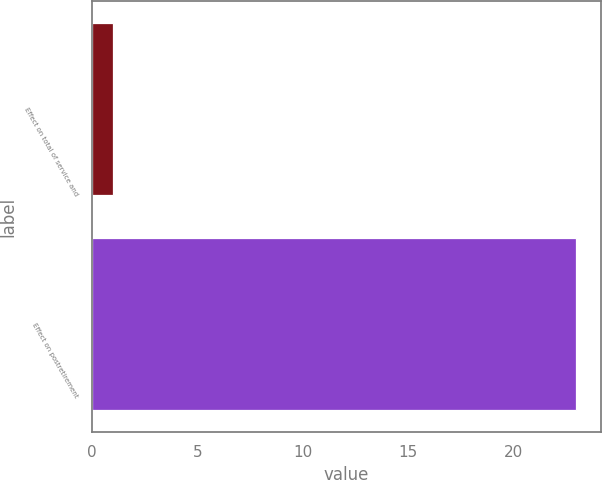<chart> <loc_0><loc_0><loc_500><loc_500><bar_chart><fcel>Effect on total of service and<fcel>Effect on postretirement<nl><fcel>1<fcel>23<nl></chart> 